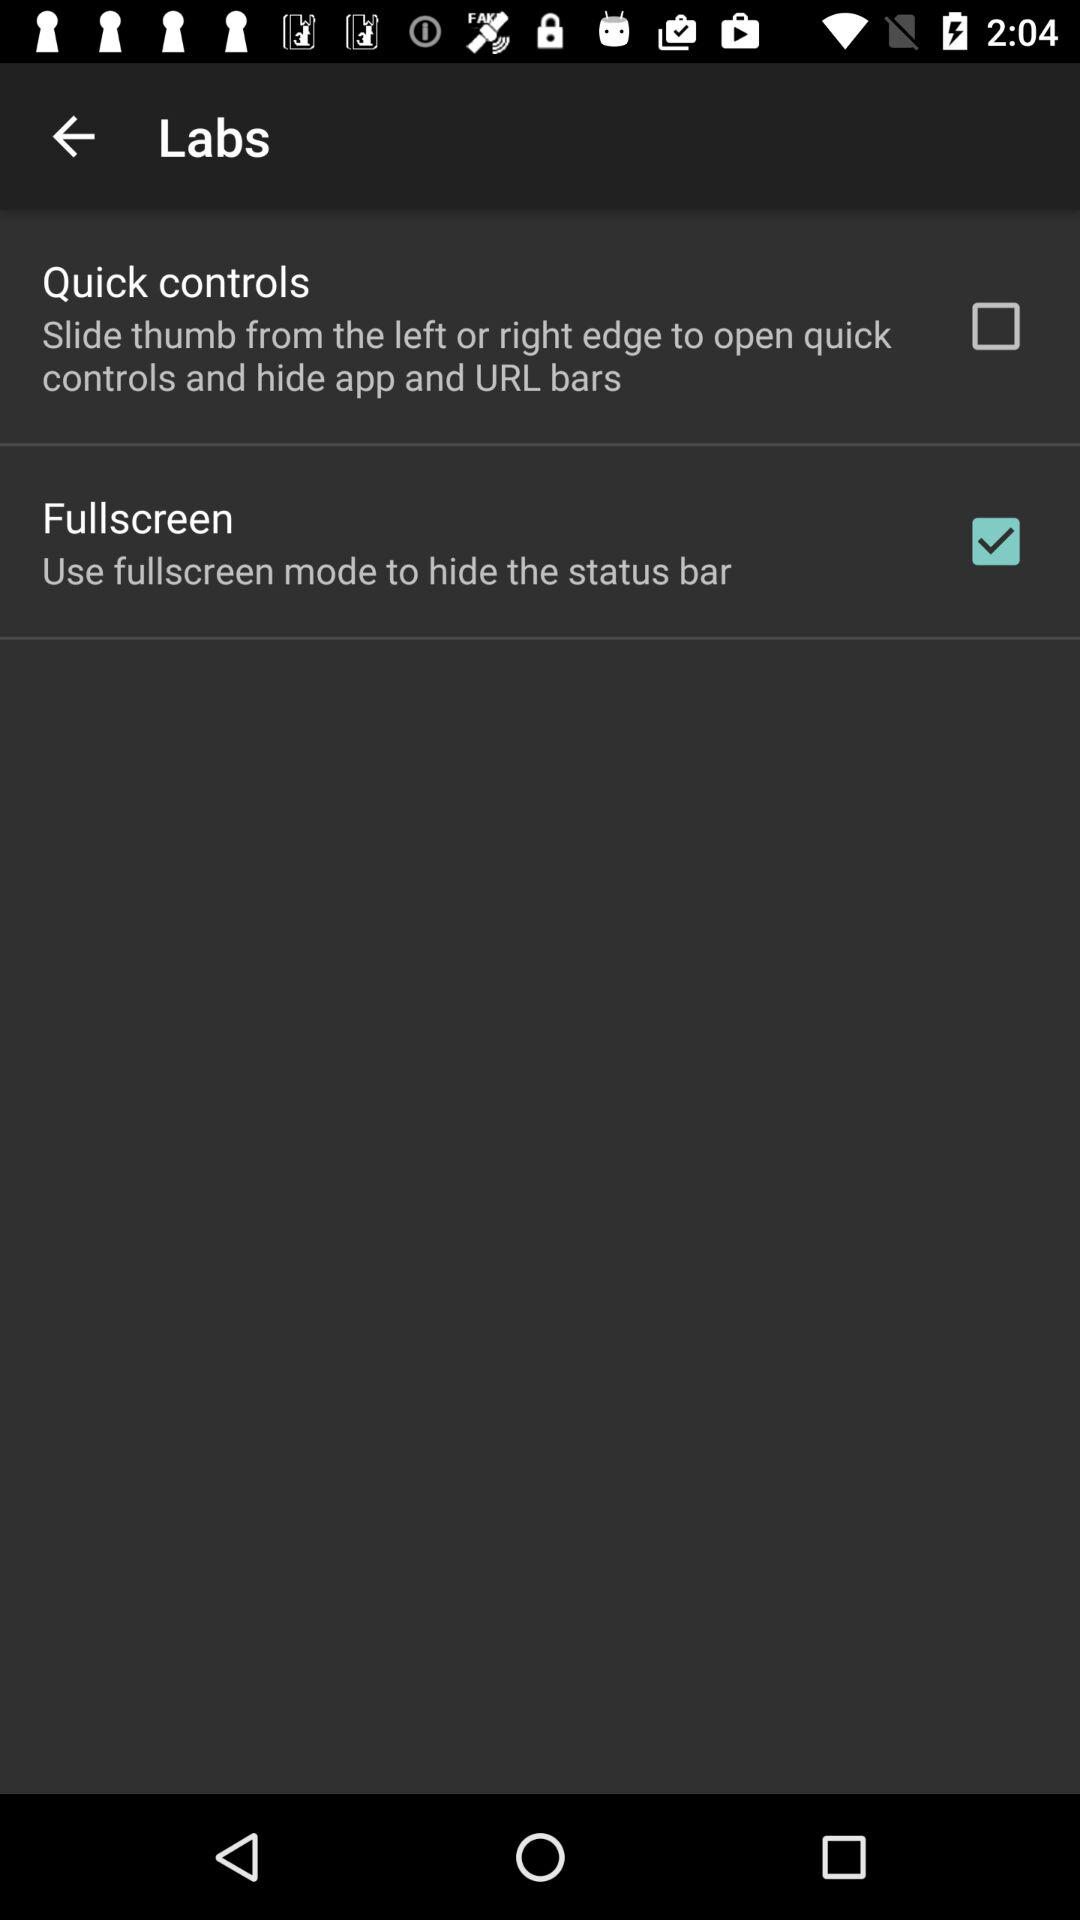Is "Fullscreen" mode off or on? "Fullscreen" mode is on. 